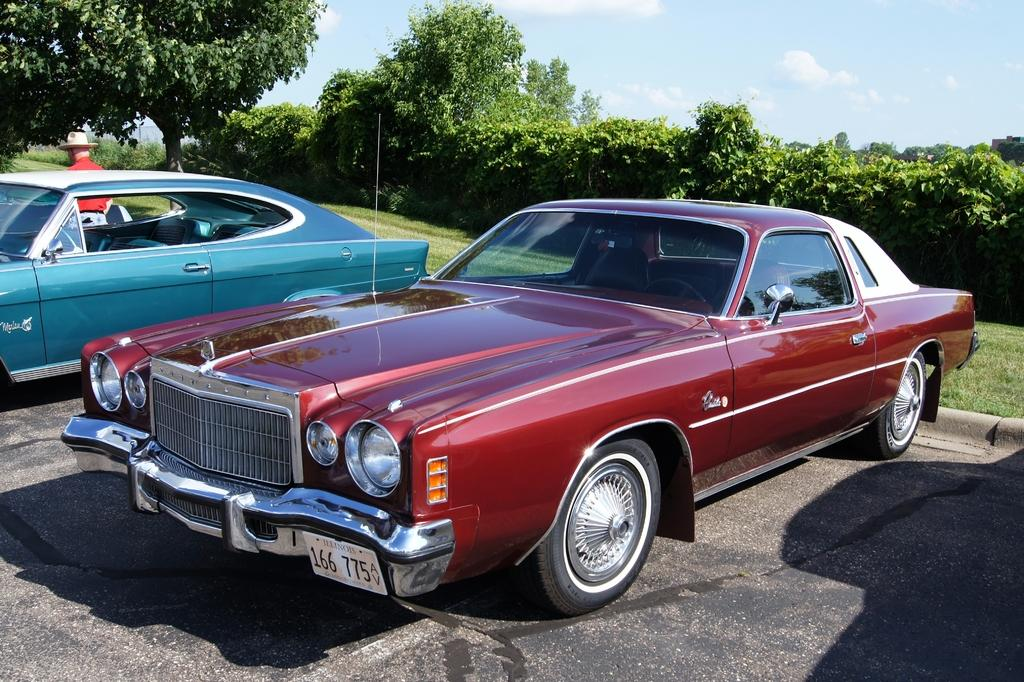How many cars are in the image? There are two cars in the image. What is the person near the car doing? There is a person standing near a car. Can you describe the person's attire? The person is wearing a hat. What can be seen in the background of the image? There are trees and the sky visible in the background of the image. What is the condition of the sky in the image? The sky has clouds in it. What type of ground surface is present in the image? There is grass on the ground. Can you tell me how many giants are in the image? There are no giants present in the image. What type of care does the judge provide to the person standing near the car? There is no judge present in the image, and therefore no such interaction can be observed. 